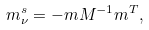<formula> <loc_0><loc_0><loc_500><loc_500>m _ { \nu } ^ { s } = - m M ^ { - 1 } m ^ { T } ,</formula> 